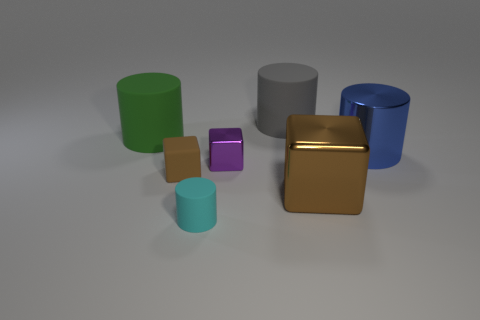Subtract all rubber blocks. How many blocks are left? 2 Add 1 cyan shiny cylinders. How many objects exist? 8 Subtract all purple blocks. How many blocks are left? 2 Subtract all cylinders. How many objects are left? 3 Add 2 gray rubber objects. How many gray rubber objects are left? 3 Add 3 brown metallic objects. How many brown metallic objects exist? 4 Subtract 1 green cylinders. How many objects are left? 6 Subtract 2 cylinders. How many cylinders are left? 2 Subtract all purple cubes. Subtract all brown cylinders. How many cubes are left? 2 Subtract all green cubes. How many yellow cylinders are left? 0 